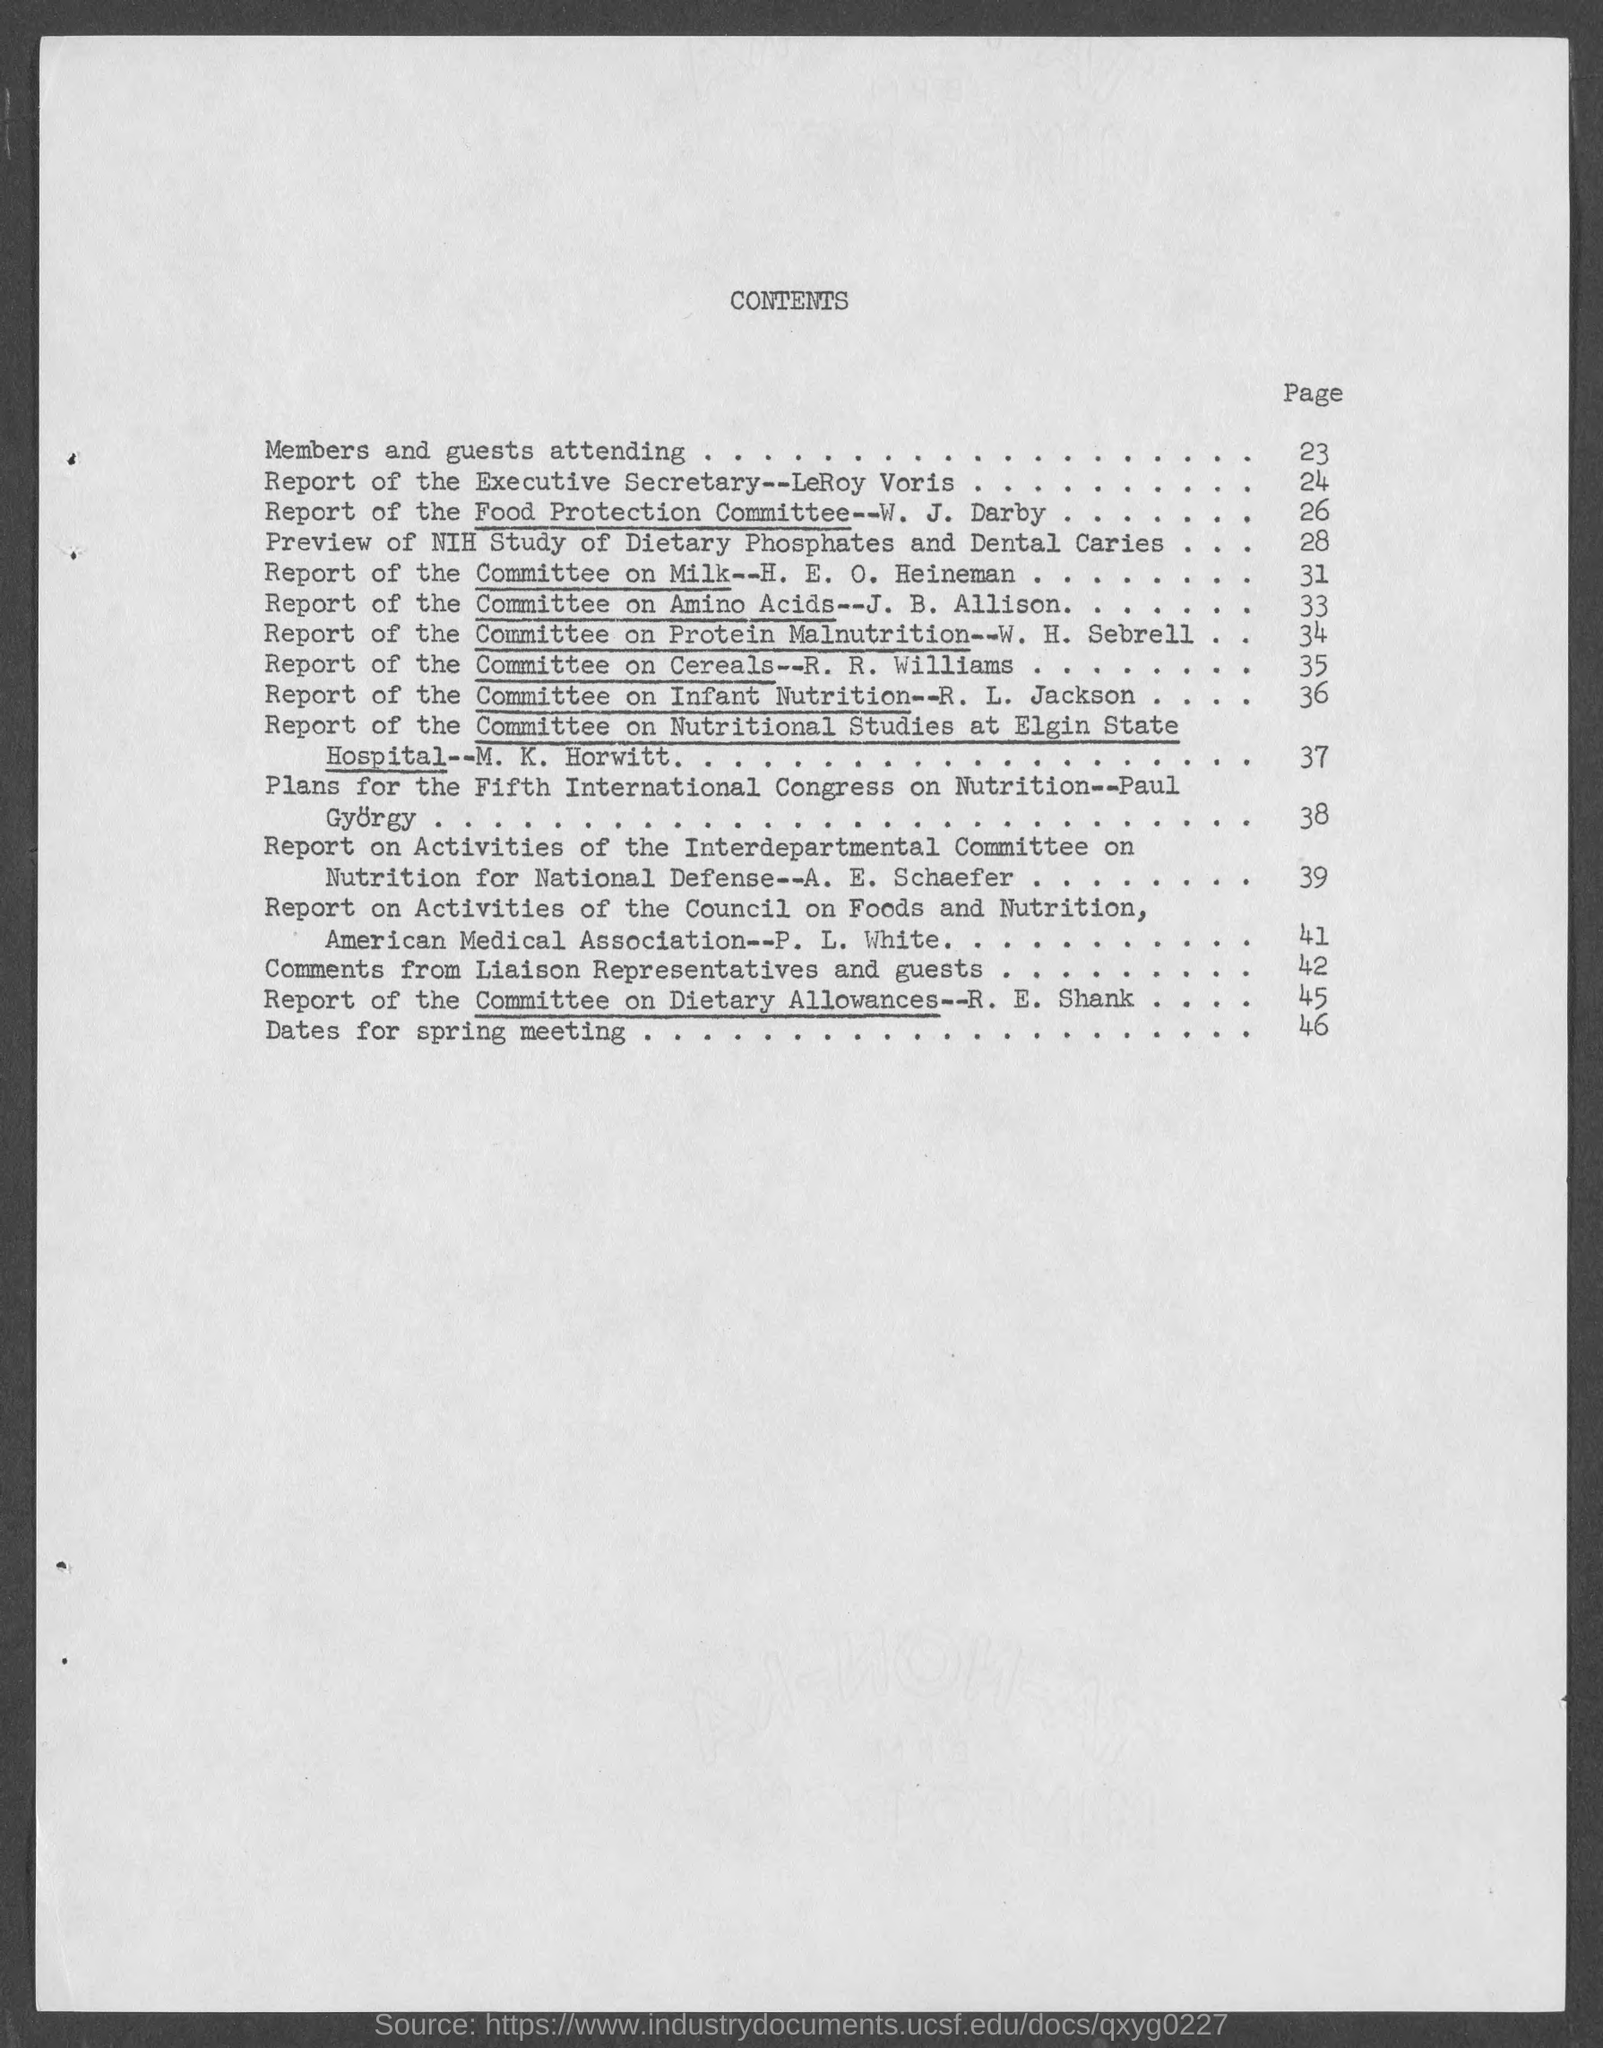What is the heading of the page?
Your answer should be very brief. Contents. What is the page number for members and guests attending ?
Keep it short and to the point. 23. What is the page number for dates for spring meeting ?
Your answer should be very brief. 46. 